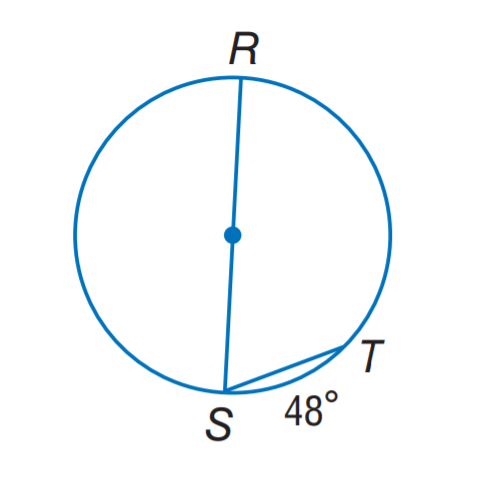Question: Find m \angle S.
Choices:
A. 24
B. 48
C. 66
D. 78
Answer with the letter. Answer: C 